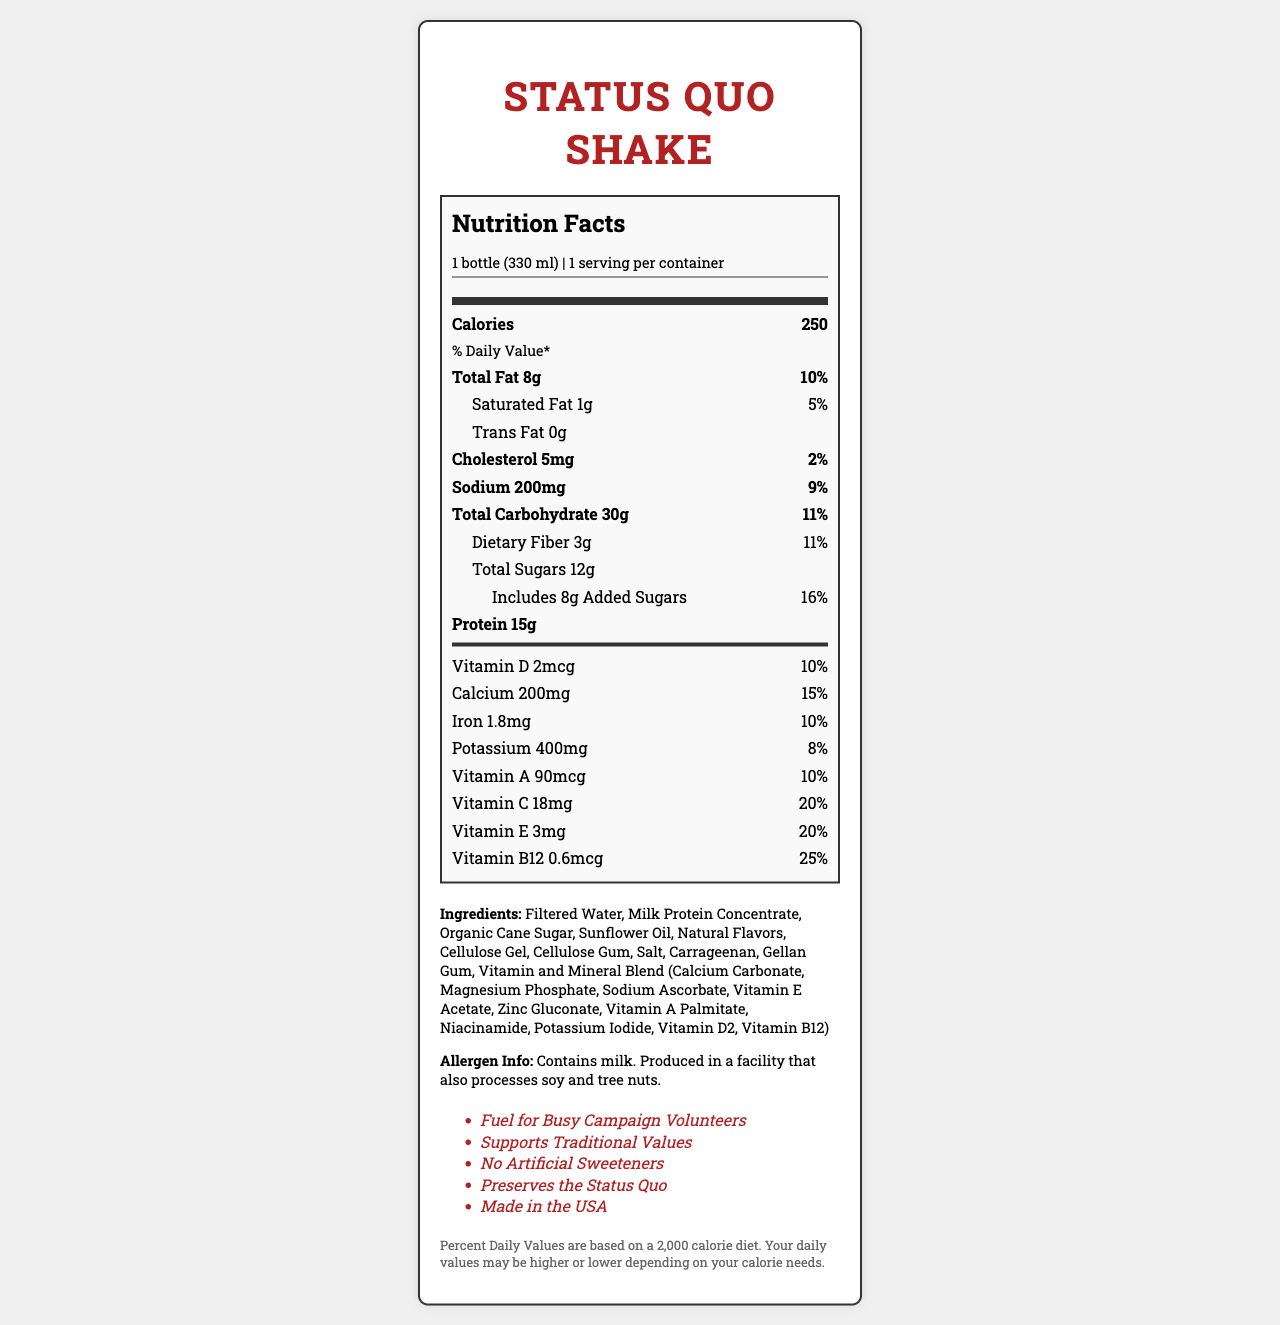what is the serving size of the Status Quo Shake? The serving size is directly mentioned at the beginning of the Nutrition Facts section.
Answer: 1 bottle (330 ml) how many calories are in one serving of the Status Quo Shake? The total calories per serving are clearly listed as 250.
Answer: 250 calories what is the daily value percentage of total fat? The daily value percentage for total fat is listed as 10%.
Answer: 10% how much protein does one serving of the Status Quo Shake contain? The protein content per serving is specified as 15 grams.
Answer: 15g what ingredients does the Status Quo Shake contain? The ingredients list is explicitly mentioned towards the end of the document.
Answer: Filtered Water, Milk Protein Concentrate, Organic Cane Sugar, Sunflower Oil, Natural Flavors, Cellulose Gel, Cellulose Gum, Salt, Carrageenan, Gellan Gum, Vitamin and Mineral Blend (Calcium Carbonate, Magnesium Phosphate, Sodium Ascorbate, Vitamin E Acetate, Zinc Gluconate, Vitamin A Palmitate, Niacinamide, Potassium Iodide, Vitamin D2, Vitamin B12) the Status Quo Shake contains which allergen(s)? The allergen information states that it contains milk.
Answer: Contains milk. what is the amount of added sugars in the Status Quo Shake? The amount of added sugars is listed as 8 grams.
Answer: 8g which vitamins or minerals have their daily value percentage given as 20%? The daily value percentages for Vitamin C and Vitamin E are both listed as 20%.
Answer: Vitamin C and Vitamin E what is the marketing claim related to the manufacturing location of the Status Quo Shake? A. Made in Canada B. Made in the USA C. Made in Mexico D. Made in Germany The document clearly states "Made in the USA" as a marketing claim.
Answer: B. Made in the USA how much calcium does the Status Quo Shake provide? A. 100mg B. 200mg C. 300mg D. 400mg The amount of calcium per serving is given as 200 mg.
Answer: B. 200mg based on the document, does the Status Quo Shake contain any artificial sweeteners? The marketing claim states "No Artificial Sweeteners," indicating the product does not contain any.
Answer: No what percent daily value does dietary fiber provide? The daily value percentage for dietary fiber is listed as 11%.
Answer: 11% is the Status Quo Shake suitable for vegans? The document states it contains milk and is produced in a facility that also processes soy and tree nuts, but it does not provide enough information to determine if the product is suitable for vegans.
Answer: Cannot be determined summarize the main points of the Status Quo Shake's Nutrition Facts Label. The document details the nutritional content including calories, fats, proteins, carbohydrates, and various vitamins and minerals, along with an ingredients list and allergen information. It also includes marketing claims about the product.
Answer: The Status Quo Shake contains 250 calories per serving with 8g of total fat (10% DV) and 15g of protein. It includes 30g of carbohydrates, 12g of sugars (8g added sugars), and several vitamins and minerals. The ingredients list includes milk protein and the product contains milk allergens. Marketing claims emphasize no artificial sweeteners, support for traditional values, and being made in the USA. 